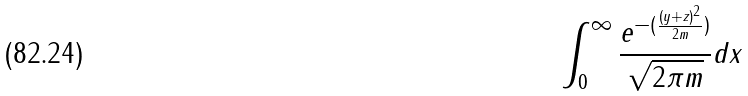<formula> <loc_0><loc_0><loc_500><loc_500>\int _ { 0 } ^ { \infty } \frac { e ^ { - ( \frac { ( y + z ) ^ { 2 } } { 2 m } ) } } { \sqrt { 2 \pi m } } d x</formula> 